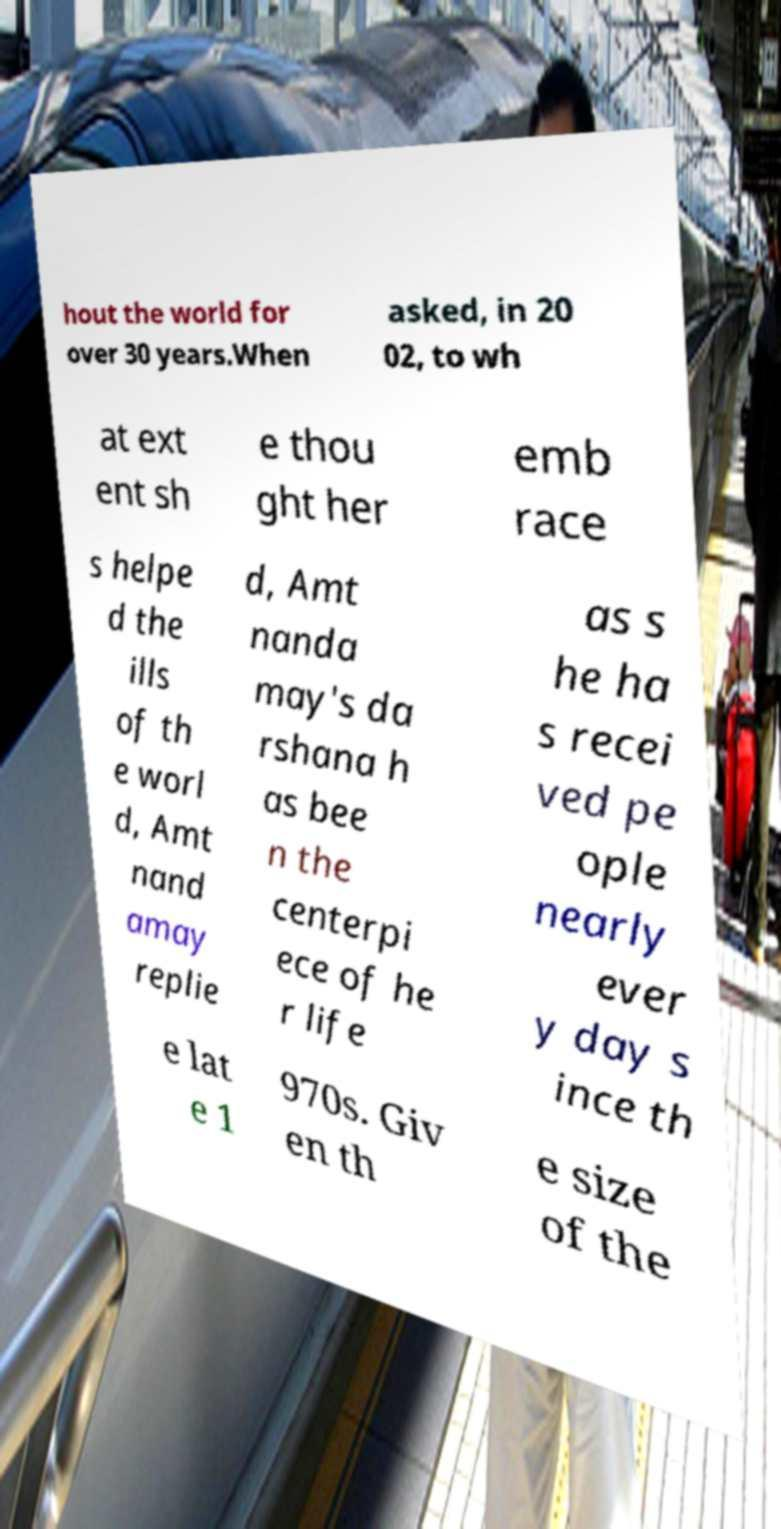Please identify and transcribe the text found in this image. hout the world for over 30 years.When asked, in 20 02, to wh at ext ent sh e thou ght her emb race s helpe d the ills of th e worl d, Amt nand amay replie d, Amt nanda may's da rshana h as bee n the centerpi ece of he r life as s he ha s recei ved pe ople nearly ever y day s ince th e lat e 1 970s. Giv en th e size of the 